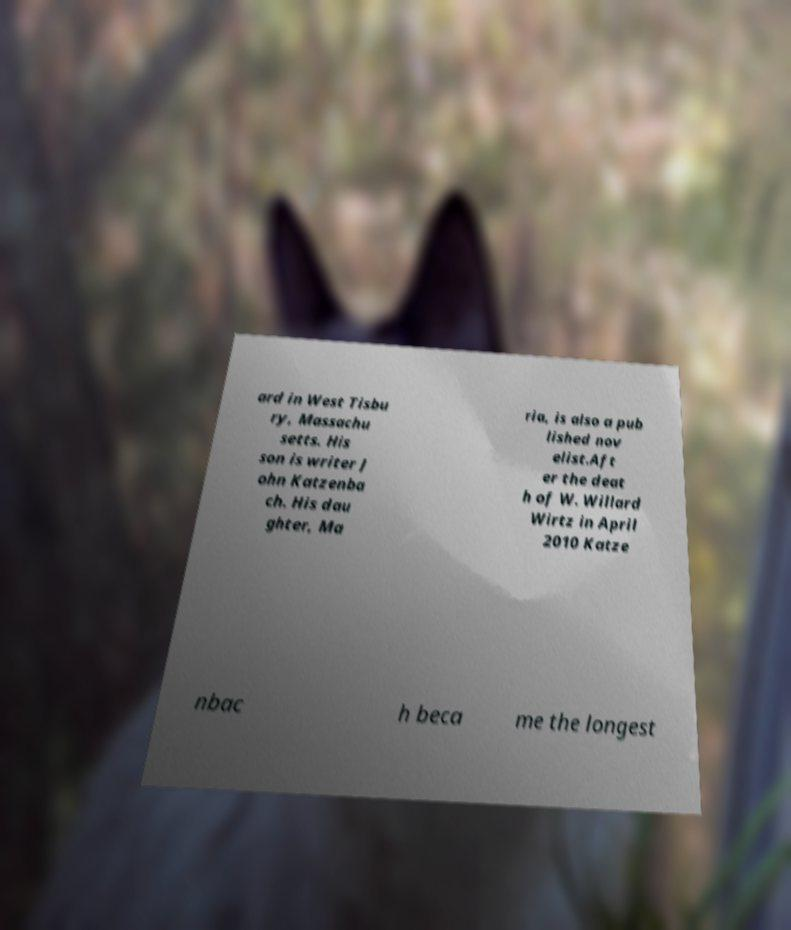Could you assist in decoding the text presented in this image and type it out clearly? ard in West Tisbu ry, Massachu setts. His son is writer J ohn Katzenba ch. His dau ghter, Ma ria, is also a pub lished nov elist.Aft er the deat h of W. Willard Wirtz in April 2010 Katze nbac h beca me the longest 